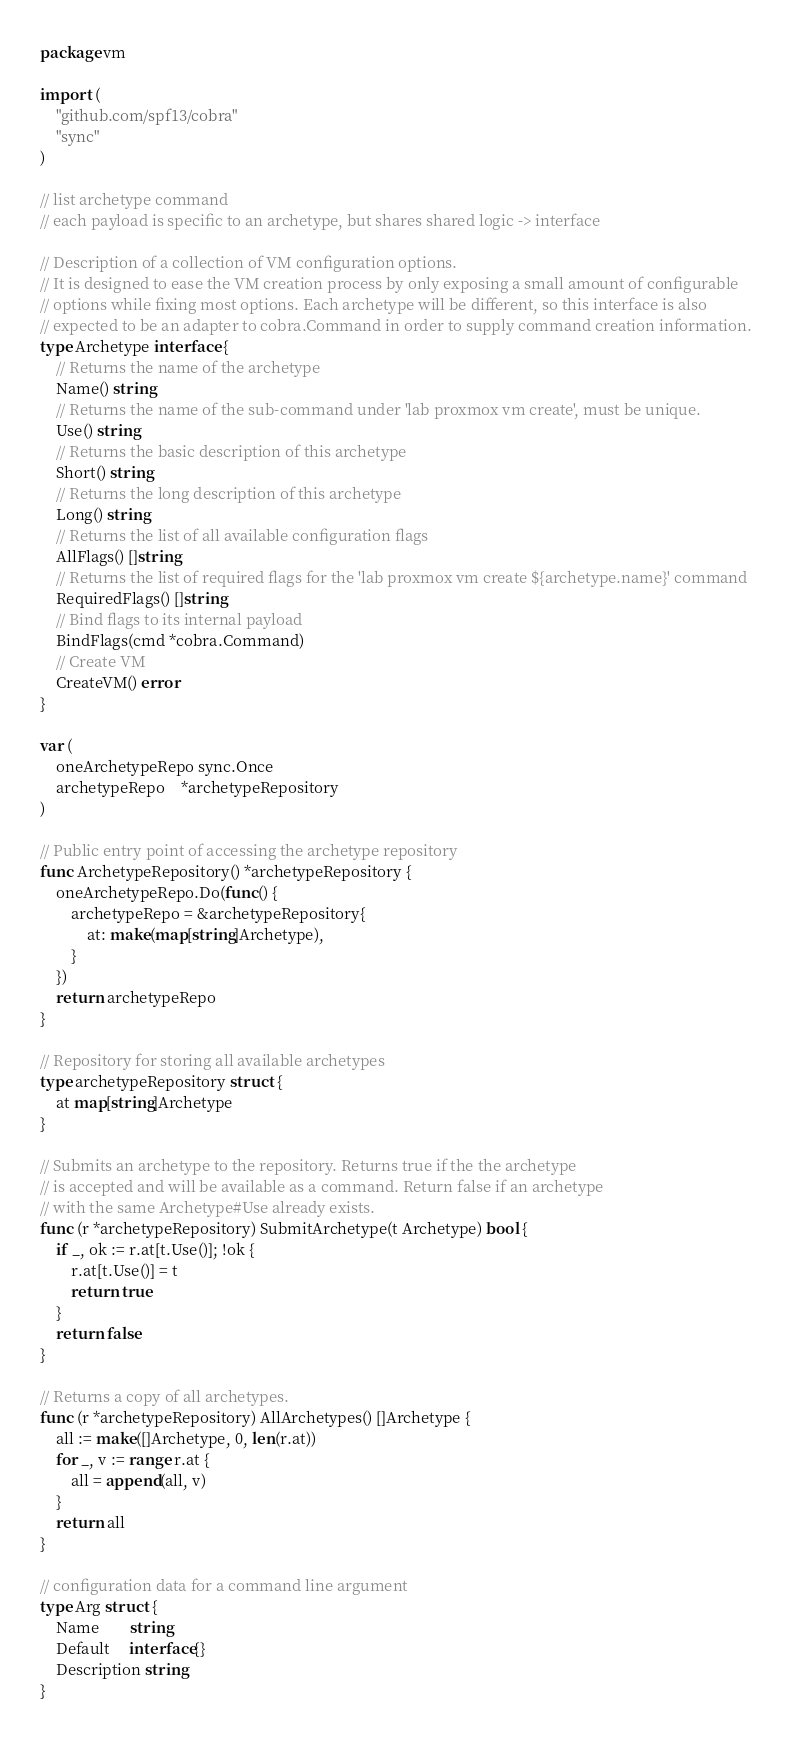<code> <loc_0><loc_0><loc_500><loc_500><_Go_>package vm

import (
	"github.com/spf13/cobra"
	"sync"
)

// list archetype command
// each payload is specific to an archetype, but shares shared logic -> interface

// Description of a collection of VM configuration options.
// It is designed to ease the VM creation process by only exposing a small amount of configurable
// options while fixing most options. Each archetype will be different, so this interface is also
// expected to be an adapter to cobra.Command in order to supply command creation information.
type Archetype interface {
	// Returns the name of the archetype
	Name() string
	// Returns the name of the sub-command under 'lab proxmox vm create', must be unique.
	Use() string
	// Returns the basic description of this archetype
	Short() string
	// Returns the long description of this archetype
	Long() string
	// Returns the list of all available configuration flags
	AllFlags() []string
	// Returns the list of required flags for the 'lab proxmox vm create ${archetype.name}' command
	RequiredFlags() []string
	// Bind flags to its internal payload
	BindFlags(cmd *cobra.Command)
	// Create VM
	CreateVM() error
}

var (
	oneArchetypeRepo sync.Once
	archetypeRepo    *archetypeRepository
)

// Public entry point of accessing the archetype repository
func ArchetypeRepository() *archetypeRepository {
	oneArchetypeRepo.Do(func() {
		archetypeRepo = &archetypeRepository{
			at: make(map[string]Archetype),
		}
	})
	return archetypeRepo
}

// Repository for storing all available archetypes
type archetypeRepository struct {
	at map[string]Archetype
}

// Submits an archetype to the repository. Returns true if the the archetype
// is accepted and will be available as a command. Return false if an archetype
// with the same Archetype#Use already exists.
func (r *archetypeRepository) SubmitArchetype(t Archetype) bool {
	if _, ok := r.at[t.Use()]; !ok {
		r.at[t.Use()] = t
		return true
	}
	return false
}

// Returns a copy of all archetypes.
func (r *archetypeRepository) AllArchetypes() []Archetype {
	all := make([]Archetype, 0, len(r.at))
	for _, v := range r.at {
		all = append(all, v)
	}
	return all
}

// configuration data for a command line argument
type Arg struct {
	Name        string
	Default     interface{}
	Description string
}
</code> 